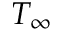Convert formula to latex. <formula><loc_0><loc_0><loc_500><loc_500>T _ { \infty }</formula> 